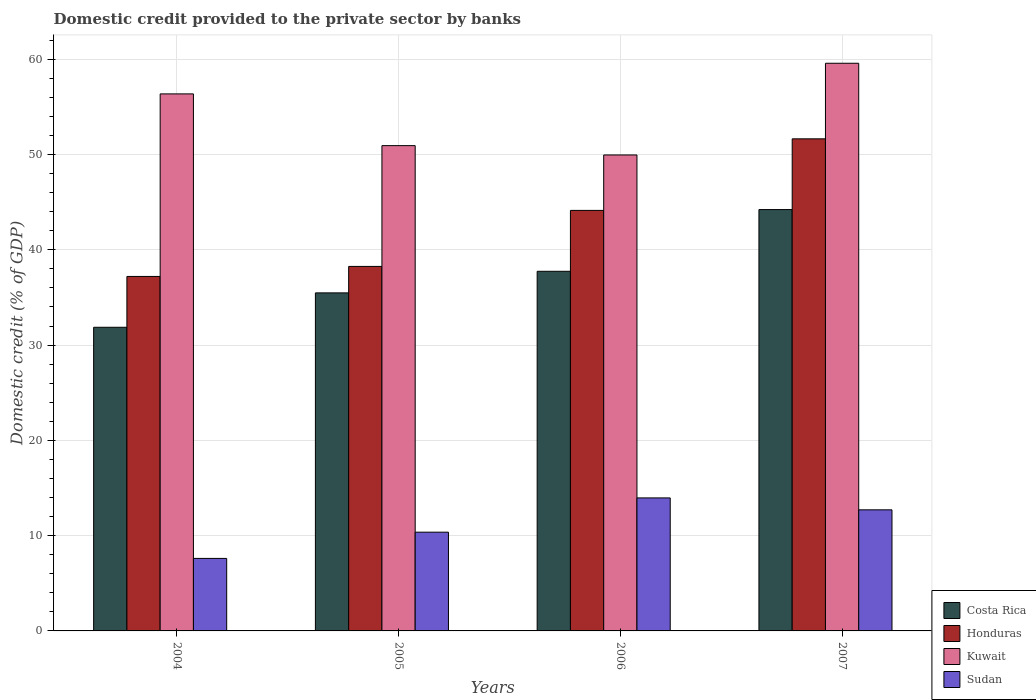Are the number of bars on each tick of the X-axis equal?
Provide a succinct answer. Yes. How many bars are there on the 3rd tick from the right?
Ensure brevity in your answer.  4. What is the label of the 2nd group of bars from the left?
Offer a terse response. 2005. In how many cases, is the number of bars for a given year not equal to the number of legend labels?
Offer a very short reply. 0. What is the domestic credit provided to the private sector by banks in Costa Rica in 2004?
Your response must be concise. 31.87. Across all years, what is the maximum domestic credit provided to the private sector by banks in Kuwait?
Give a very brief answer. 59.58. Across all years, what is the minimum domestic credit provided to the private sector by banks in Kuwait?
Make the answer very short. 49.95. In which year was the domestic credit provided to the private sector by banks in Honduras minimum?
Make the answer very short. 2004. What is the total domestic credit provided to the private sector by banks in Sudan in the graph?
Your response must be concise. 44.64. What is the difference between the domestic credit provided to the private sector by banks in Honduras in 2006 and that in 2007?
Give a very brief answer. -7.51. What is the difference between the domestic credit provided to the private sector by banks in Costa Rica in 2005 and the domestic credit provided to the private sector by banks in Honduras in 2004?
Provide a succinct answer. -1.73. What is the average domestic credit provided to the private sector by banks in Kuwait per year?
Offer a very short reply. 54.21. In the year 2004, what is the difference between the domestic credit provided to the private sector by banks in Kuwait and domestic credit provided to the private sector by banks in Honduras?
Your answer should be very brief. 19.16. What is the ratio of the domestic credit provided to the private sector by banks in Costa Rica in 2004 to that in 2006?
Your response must be concise. 0.84. Is the domestic credit provided to the private sector by banks in Kuwait in 2004 less than that in 2007?
Make the answer very short. Yes. What is the difference between the highest and the second highest domestic credit provided to the private sector by banks in Honduras?
Give a very brief answer. 7.51. What is the difference between the highest and the lowest domestic credit provided to the private sector by banks in Costa Rica?
Offer a terse response. 12.35. Is the sum of the domestic credit provided to the private sector by banks in Sudan in 2005 and 2007 greater than the maximum domestic credit provided to the private sector by banks in Costa Rica across all years?
Ensure brevity in your answer.  No. Is it the case that in every year, the sum of the domestic credit provided to the private sector by banks in Kuwait and domestic credit provided to the private sector by banks in Honduras is greater than the sum of domestic credit provided to the private sector by banks in Sudan and domestic credit provided to the private sector by banks in Costa Rica?
Keep it short and to the point. Yes. What does the 4th bar from the left in 2004 represents?
Give a very brief answer. Sudan. What does the 3rd bar from the right in 2005 represents?
Your response must be concise. Honduras. Is it the case that in every year, the sum of the domestic credit provided to the private sector by banks in Costa Rica and domestic credit provided to the private sector by banks in Kuwait is greater than the domestic credit provided to the private sector by banks in Honduras?
Offer a terse response. Yes. How many years are there in the graph?
Ensure brevity in your answer.  4. Are the values on the major ticks of Y-axis written in scientific E-notation?
Your answer should be compact. No. What is the title of the graph?
Offer a very short reply. Domestic credit provided to the private sector by banks. Does "American Samoa" appear as one of the legend labels in the graph?
Offer a terse response. No. What is the label or title of the X-axis?
Offer a terse response. Years. What is the label or title of the Y-axis?
Your answer should be very brief. Domestic credit (% of GDP). What is the Domestic credit (% of GDP) in Costa Rica in 2004?
Provide a short and direct response. 31.87. What is the Domestic credit (% of GDP) of Honduras in 2004?
Give a very brief answer. 37.2. What is the Domestic credit (% of GDP) in Kuwait in 2004?
Your response must be concise. 56.36. What is the Domestic credit (% of GDP) in Sudan in 2004?
Provide a succinct answer. 7.61. What is the Domestic credit (% of GDP) in Costa Rica in 2005?
Make the answer very short. 35.48. What is the Domestic credit (% of GDP) in Honduras in 2005?
Your answer should be compact. 38.26. What is the Domestic credit (% of GDP) in Kuwait in 2005?
Make the answer very short. 50.93. What is the Domestic credit (% of GDP) in Sudan in 2005?
Provide a succinct answer. 10.36. What is the Domestic credit (% of GDP) of Costa Rica in 2006?
Give a very brief answer. 37.75. What is the Domestic credit (% of GDP) of Honduras in 2006?
Your response must be concise. 44.14. What is the Domestic credit (% of GDP) in Kuwait in 2006?
Your answer should be very brief. 49.95. What is the Domestic credit (% of GDP) in Sudan in 2006?
Your answer should be compact. 13.96. What is the Domestic credit (% of GDP) in Costa Rica in 2007?
Your answer should be compact. 44.22. What is the Domestic credit (% of GDP) in Honduras in 2007?
Provide a short and direct response. 51.65. What is the Domestic credit (% of GDP) in Kuwait in 2007?
Offer a terse response. 59.58. What is the Domestic credit (% of GDP) in Sudan in 2007?
Ensure brevity in your answer.  12.71. Across all years, what is the maximum Domestic credit (% of GDP) of Costa Rica?
Ensure brevity in your answer.  44.22. Across all years, what is the maximum Domestic credit (% of GDP) of Honduras?
Provide a succinct answer. 51.65. Across all years, what is the maximum Domestic credit (% of GDP) in Kuwait?
Your response must be concise. 59.58. Across all years, what is the maximum Domestic credit (% of GDP) in Sudan?
Offer a very short reply. 13.96. Across all years, what is the minimum Domestic credit (% of GDP) of Costa Rica?
Give a very brief answer. 31.87. Across all years, what is the minimum Domestic credit (% of GDP) of Honduras?
Ensure brevity in your answer.  37.2. Across all years, what is the minimum Domestic credit (% of GDP) of Kuwait?
Make the answer very short. 49.95. Across all years, what is the minimum Domestic credit (% of GDP) of Sudan?
Give a very brief answer. 7.61. What is the total Domestic credit (% of GDP) of Costa Rica in the graph?
Ensure brevity in your answer.  149.32. What is the total Domestic credit (% of GDP) in Honduras in the graph?
Offer a terse response. 171.24. What is the total Domestic credit (% of GDP) of Kuwait in the graph?
Ensure brevity in your answer.  216.83. What is the total Domestic credit (% of GDP) in Sudan in the graph?
Provide a succinct answer. 44.64. What is the difference between the Domestic credit (% of GDP) in Costa Rica in 2004 and that in 2005?
Your answer should be very brief. -3.61. What is the difference between the Domestic credit (% of GDP) of Honduras in 2004 and that in 2005?
Your answer should be very brief. -1.05. What is the difference between the Domestic credit (% of GDP) of Kuwait in 2004 and that in 2005?
Offer a very short reply. 5.43. What is the difference between the Domestic credit (% of GDP) in Sudan in 2004 and that in 2005?
Give a very brief answer. -2.75. What is the difference between the Domestic credit (% of GDP) of Costa Rica in 2004 and that in 2006?
Keep it short and to the point. -5.88. What is the difference between the Domestic credit (% of GDP) of Honduras in 2004 and that in 2006?
Ensure brevity in your answer.  -6.93. What is the difference between the Domestic credit (% of GDP) in Kuwait in 2004 and that in 2006?
Your answer should be very brief. 6.41. What is the difference between the Domestic credit (% of GDP) of Sudan in 2004 and that in 2006?
Your answer should be compact. -6.35. What is the difference between the Domestic credit (% of GDP) of Costa Rica in 2004 and that in 2007?
Ensure brevity in your answer.  -12.35. What is the difference between the Domestic credit (% of GDP) in Honduras in 2004 and that in 2007?
Provide a succinct answer. -14.44. What is the difference between the Domestic credit (% of GDP) of Kuwait in 2004 and that in 2007?
Your answer should be compact. -3.22. What is the difference between the Domestic credit (% of GDP) of Sudan in 2004 and that in 2007?
Keep it short and to the point. -5.1. What is the difference between the Domestic credit (% of GDP) in Costa Rica in 2005 and that in 2006?
Your answer should be compact. -2.27. What is the difference between the Domestic credit (% of GDP) in Honduras in 2005 and that in 2006?
Your answer should be very brief. -5.88. What is the difference between the Domestic credit (% of GDP) of Kuwait in 2005 and that in 2006?
Provide a short and direct response. 0.98. What is the difference between the Domestic credit (% of GDP) in Sudan in 2005 and that in 2006?
Keep it short and to the point. -3.6. What is the difference between the Domestic credit (% of GDP) of Costa Rica in 2005 and that in 2007?
Provide a short and direct response. -8.74. What is the difference between the Domestic credit (% of GDP) of Honduras in 2005 and that in 2007?
Provide a short and direct response. -13.39. What is the difference between the Domestic credit (% of GDP) in Kuwait in 2005 and that in 2007?
Ensure brevity in your answer.  -8.65. What is the difference between the Domestic credit (% of GDP) of Sudan in 2005 and that in 2007?
Give a very brief answer. -2.34. What is the difference between the Domestic credit (% of GDP) of Costa Rica in 2006 and that in 2007?
Offer a terse response. -6.48. What is the difference between the Domestic credit (% of GDP) of Honduras in 2006 and that in 2007?
Your answer should be compact. -7.51. What is the difference between the Domestic credit (% of GDP) of Kuwait in 2006 and that in 2007?
Provide a succinct answer. -9.63. What is the difference between the Domestic credit (% of GDP) of Sudan in 2006 and that in 2007?
Your answer should be compact. 1.25. What is the difference between the Domestic credit (% of GDP) in Costa Rica in 2004 and the Domestic credit (% of GDP) in Honduras in 2005?
Give a very brief answer. -6.39. What is the difference between the Domestic credit (% of GDP) of Costa Rica in 2004 and the Domestic credit (% of GDP) of Kuwait in 2005?
Your response must be concise. -19.06. What is the difference between the Domestic credit (% of GDP) in Costa Rica in 2004 and the Domestic credit (% of GDP) in Sudan in 2005?
Give a very brief answer. 21.5. What is the difference between the Domestic credit (% of GDP) in Honduras in 2004 and the Domestic credit (% of GDP) in Kuwait in 2005?
Offer a very short reply. -13.73. What is the difference between the Domestic credit (% of GDP) of Honduras in 2004 and the Domestic credit (% of GDP) of Sudan in 2005?
Provide a short and direct response. 26.84. What is the difference between the Domestic credit (% of GDP) in Kuwait in 2004 and the Domestic credit (% of GDP) in Sudan in 2005?
Your answer should be compact. 46. What is the difference between the Domestic credit (% of GDP) in Costa Rica in 2004 and the Domestic credit (% of GDP) in Honduras in 2006?
Provide a succinct answer. -12.27. What is the difference between the Domestic credit (% of GDP) in Costa Rica in 2004 and the Domestic credit (% of GDP) in Kuwait in 2006?
Offer a very short reply. -18.08. What is the difference between the Domestic credit (% of GDP) of Costa Rica in 2004 and the Domestic credit (% of GDP) of Sudan in 2006?
Provide a succinct answer. 17.91. What is the difference between the Domestic credit (% of GDP) of Honduras in 2004 and the Domestic credit (% of GDP) of Kuwait in 2006?
Offer a terse response. -12.75. What is the difference between the Domestic credit (% of GDP) of Honduras in 2004 and the Domestic credit (% of GDP) of Sudan in 2006?
Offer a very short reply. 23.24. What is the difference between the Domestic credit (% of GDP) in Kuwait in 2004 and the Domestic credit (% of GDP) in Sudan in 2006?
Offer a very short reply. 42.4. What is the difference between the Domestic credit (% of GDP) of Costa Rica in 2004 and the Domestic credit (% of GDP) of Honduras in 2007?
Your answer should be compact. -19.78. What is the difference between the Domestic credit (% of GDP) of Costa Rica in 2004 and the Domestic credit (% of GDP) of Kuwait in 2007?
Keep it short and to the point. -27.71. What is the difference between the Domestic credit (% of GDP) in Costa Rica in 2004 and the Domestic credit (% of GDP) in Sudan in 2007?
Make the answer very short. 19.16. What is the difference between the Domestic credit (% of GDP) of Honduras in 2004 and the Domestic credit (% of GDP) of Kuwait in 2007?
Make the answer very short. -22.37. What is the difference between the Domestic credit (% of GDP) of Honduras in 2004 and the Domestic credit (% of GDP) of Sudan in 2007?
Offer a very short reply. 24.5. What is the difference between the Domestic credit (% of GDP) of Kuwait in 2004 and the Domestic credit (% of GDP) of Sudan in 2007?
Ensure brevity in your answer.  43.66. What is the difference between the Domestic credit (% of GDP) of Costa Rica in 2005 and the Domestic credit (% of GDP) of Honduras in 2006?
Offer a very short reply. -8.66. What is the difference between the Domestic credit (% of GDP) in Costa Rica in 2005 and the Domestic credit (% of GDP) in Kuwait in 2006?
Your answer should be compact. -14.47. What is the difference between the Domestic credit (% of GDP) of Costa Rica in 2005 and the Domestic credit (% of GDP) of Sudan in 2006?
Ensure brevity in your answer.  21.52. What is the difference between the Domestic credit (% of GDP) of Honduras in 2005 and the Domestic credit (% of GDP) of Kuwait in 2006?
Make the answer very short. -11.7. What is the difference between the Domestic credit (% of GDP) of Honduras in 2005 and the Domestic credit (% of GDP) of Sudan in 2006?
Offer a terse response. 24.3. What is the difference between the Domestic credit (% of GDP) in Kuwait in 2005 and the Domestic credit (% of GDP) in Sudan in 2006?
Your answer should be compact. 36.97. What is the difference between the Domestic credit (% of GDP) of Costa Rica in 2005 and the Domestic credit (% of GDP) of Honduras in 2007?
Your response must be concise. -16.17. What is the difference between the Domestic credit (% of GDP) of Costa Rica in 2005 and the Domestic credit (% of GDP) of Kuwait in 2007?
Make the answer very short. -24.1. What is the difference between the Domestic credit (% of GDP) of Costa Rica in 2005 and the Domestic credit (% of GDP) of Sudan in 2007?
Offer a terse response. 22.77. What is the difference between the Domestic credit (% of GDP) of Honduras in 2005 and the Domestic credit (% of GDP) of Kuwait in 2007?
Keep it short and to the point. -21.32. What is the difference between the Domestic credit (% of GDP) of Honduras in 2005 and the Domestic credit (% of GDP) of Sudan in 2007?
Your answer should be compact. 25.55. What is the difference between the Domestic credit (% of GDP) of Kuwait in 2005 and the Domestic credit (% of GDP) of Sudan in 2007?
Your answer should be compact. 38.23. What is the difference between the Domestic credit (% of GDP) in Costa Rica in 2006 and the Domestic credit (% of GDP) in Honduras in 2007?
Ensure brevity in your answer.  -13.9. What is the difference between the Domestic credit (% of GDP) of Costa Rica in 2006 and the Domestic credit (% of GDP) of Kuwait in 2007?
Ensure brevity in your answer.  -21.83. What is the difference between the Domestic credit (% of GDP) of Costa Rica in 2006 and the Domestic credit (% of GDP) of Sudan in 2007?
Ensure brevity in your answer.  25.04. What is the difference between the Domestic credit (% of GDP) of Honduras in 2006 and the Domestic credit (% of GDP) of Kuwait in 2007?
Your answer should be very brief. -15.44. What is the difference between the Domestic credit (% of GDP) in Honduras in 2006 and the Domestic credit (% of GDP) in Sudan in 2007?
Offer a very short reply. 31.43. What is the difference between the Domestic credit (% of GDP) of Kuwait in 2006 and the Domestic credit (% of GDP) of Sudan in 2007?
Your answer should be very brief. 37.25. What is the average Domestic credit (% of GDP) in Costa Rica per year?
Your answer should be very brief. 37.33. What is the average Domestic credit (% of GDP) in Honduras per year?
Your answer should be very brief. 42.81. What is the average Domestic credit (% of GDP) in Kuwait per year?
Offer a very short reply. 54.21. What is the average Domestic credit (% of GDP) in Sudan per year?
Provide a succinct answer. 11.16. In the year 2004, what is the difference between the Domestic credit (% of GDP) of Costa Rica and Domestic credit (% of GDP) of Honduras?
Your response must be concise. -5.34. In the year 2004, what is the difference between the Domestic credit (% of GDP) of Costa Rica and Domestic credit (% of GDP) of Kuwait?
Provide a succinct answer. -24.49. In the year 2004, what is the difference between the Domestic credit (% of GDP) of Costa Rica and Domestic credit (% of GDP) of Sudan?
Your answer should be compact. 24.26. In the year 2004, what is the difference between the Domestic credit (% of GDP) in Honduras and Domestic credit (% of GDP) in Kuwait?
Offer a very short reply. -19.16. In the year 2004, what is the difference between the Domestic credit (% of GDP) in Honduras and Domestic credit (% of GDP) in Sudan?
Ensure brevity in your answer.  29.59. In the year 2004, what is the difference between the Domestic credit (% of GDP) in Kuwait and Domestic credit (% of GDP) in Sudan?
Give a very brief answer. 48.75. In the year 2005, what is the difference between the Domestic credit (% of GDP) in Costa Rica and Domestic credit (% of GDP) in Honduras?
Make the answer very short. -2.78. In the year 2005, what is the difference between the Domestic credit (% of GDP) of Costa Rica and Domestic credit (% of GDP) of Kuwait?
Offer a very short reply. -15.45. In the year 2005, what is the difference between the Domestic credit (% of GDP) of Costa Rica and Domestic credit (% of GDP) of Sudan?
Ensure brevity in your answer.  25.11. In the year 2005, what is the difference between the Domestic credit (% of GDP) in Honduras and Domestic credit (% of GDP) in Kuwait?
Offer a terse response. -12.68. In the year 2005, what is the difference between the Domestic credit (% of GDP) in Honduras and Domestic credit (% of GDP) in Sudan?
Make the answer very short. 27.89. In the year 2005, what is the difference between the Domestic credit (% of GDP) of Kuwait and Domestic credit (% of GDP) of Sudan?
Provide a succinct answer. 40.57. In the year 2006, what is the difference between the Domestic credit (% of GDP) in Costa Rica and Domestic credit (% of GDP) in Honduras?
Offer a terse response. -6.39. In the year 2006, what is the difference between the Domestic credit (% of GDP) in Costa Rica and Domestic credit (% of GDP) in Kuwait?
Your answer should be very brief. -12.21. In the year 2006, what is the difference between the Domestic credit (% of GDP) in Costa Rica and Domestic credit (% of GDP) in Sudan?
Your answer should be very brief. 23.79. In the year 2006, what is the difference between the Domestic credit (% of GDP) of Honduras and Domestic credit (% of GDP) of Kuwait?
Your answer should be compact. -5.82. In the year 2006, what is the difference between the Domestic credit (% of GDP) of Honduras and Domestic credit (% of GDP) of Sudan?
Give a very brief answer. 30.18. In the year 2006, what is the difference between the Domestic credit (% of GDP) of Kuwait and Domestic credit (% of GDP) of Sudan?
Provide a succinct answer. 35.99. In the year 2007, what is the difference between the Domestic credit (% of GDP) in Costa Rica and Domestic credit (% of GDP) in Honduras?
Offer a very short reply. -7.42. In the year 2007, what is the difference between the Domestic credit (% of GDP) of Costa Rica and Domestic credit (% of GDP) of Kuwait?
Provide a succinct answer. -15.36. In the year 2007, what is the difference between the Domestic credit (% of GDP) in Costa Rica and Domestic credit (% of GDP) in Sudan?
Your answer should be very brief. 31.51. In the year 2007, what is the difference between the Domestic credit (% of GDP) of Honduras and Domestic credit (% of GDP) of Kuwait?
Your response must be concise. -7.93. In the year 2007, what is the difference between the Domestic credit (% of GDP) of Honduras and Domestic credit (% of GDP) of Sudan?
Offer a very short reply. 38.94. In the year 2007, what is the difference between the Domestic credit (% of GDP) of Kuwait and Domestic credit (% of GDP) of Sudan?
Ensure brevity in your answer.  46.87. What is the ratio of the Domestic credit (% of GDP) in Costa Rica in 2004 to that in 2005?
Provide a short and direct response. 0.9. What is the ratio of the Domestic credit (% of GDP) of Honduras in 2004 to that in 2005?
Keep it short and to the point. 0.97. What is the ratio of the Domestic credit (% of GDP) of Kuwait in 2004 to that in 2005?
Offer a very short reply. 1.11. What is the ratio of the Domestic credit (% of GDP) of Sudan in 2004 to that in 2005?
Offer a terse response. 0.73. What is the ratio of the Domestic credit (% of GDP) of Costa Rica in 2004 to that in 2006?
Give a very brief answer. 0.84. What is the ratio of the Domestic credit (% of GDP) of Honduras in 2004 to that in 2006?
Provide a succinct answer. 0.84. What is the ratio of the Domestic credit (% of GDP) of Kuwait in 2004 to that in 2006?
Provide a succinct answer. 1.13. What is the ratio of the Domestic credit (% of GDP) in Sudan in 2004 to that in 2006?
Ensure brevity in your answer.  0.55. What is the ratio of the Domestic credit (% of GDP) of Costa Rica in 2004 to that in 2007?
Keep it short and to the point. 0.72. What is the ratio of the Domestic credit (% of GDP) of Honduras in 2004 to that in 2007?
Your answer should be compact. 0.72. What is the ratio of the Domestic credit (% of GDP) of Kuwait in 2004 to that in 2007?
Keep it short and to the point. 0.95. What is the ratio of the Domestic credit (% of GDP) of Sudan in 2004 to that in 2007?
Offer a terse response. 0.6. What is the ratio of the Domestic credit (% of GDP) of Costa Rica in 2005 to that in 2006?
Make the answer very short. 0.94. What is the ratio of the Domestic credit (% of GDP) in Honduras in 2005 to that in 2006?
Your answer should be very brief. 0.87. What is the ratio of the Domestic credit (% of GDP) of Kuwait in 2005 to that in 2006?
Offer a very short reply. 1.02. What is the ratio of the Domestic credit (% of GDP) in Sudan in 2005 to that in 2006?
Keep it short and to the point. 0.74. What is the ratio of the Domestic credit (% of GDP) of Costa Rica in 2005 to that in 2007?
Your answer should be compact. 0.8. What is the ratio of the Domestic credit (% of GDP) of Honduras in 2005 to that in 2007?
Provide a succinct answer. 0.74. What is the ratio of the Domestic credit (% of GDP) in Kuwait in 2005 to that in 2007?
Give a very brief answer. 0.85. What is the ratio of the Domestic credit (% of GDP) of Sudan in 2005 to that in 2007?
Ensure brevity in your answer.  0.82. What is the ratio of the Domestic credit (% of GDP) in Costa Rica in 2006 to that in 2007?
Ensure brevity in your answer.  0.85. What is the ratio of the Domestic credit (% of GDP) of Honduras in 2006 to that in 2007?
Keep it short and to the point. 0.85. What is the ratio of the Domestic credit (% of GDP) of Kuwait in 2006 to that in 2007?
Provide a succinct answer. 0.84. What is the ratio of the Domestic credit (% of GDP) in Sudan in 2006 to that in 2007?
Provide a short and direct response. 1.1. What is the difference between the highest and the second highest Domestic credit (% of GDP) in Costa Rica?
Your response must be concise. 6.48. What is the difference between the highest and the second highest Domestic credit (% of GDP) of Honduras?
Your answer should be compact. 7.51. What is the difference between the highest and the second highest Domestic credit (% of GDP) of Kuwait?
Offer a terse response. 3.22. What is the difference between the highest and the second highest Domestic credit (% of GDP) of Sudan?
Your answer should be very brief. 1.25. What is the difference between the highest and the lowest Domestic credit (% of GDP) in Costa Rica?
Provide a short and direct response. 12.35. What is the difference between the highest and the lowest Domestic credit (% of GDP) of Honduras?
Provide a succinct answer. 14.44. What is the difference between the highest and the lowest Domestic credit (% of GDP) in Kuwait?
Make the answer very short. 9.63. What is the difference between the highest and the lowest Domestic credit (% of GDP) of Sudan?
Offer a terse response. 6.35. 